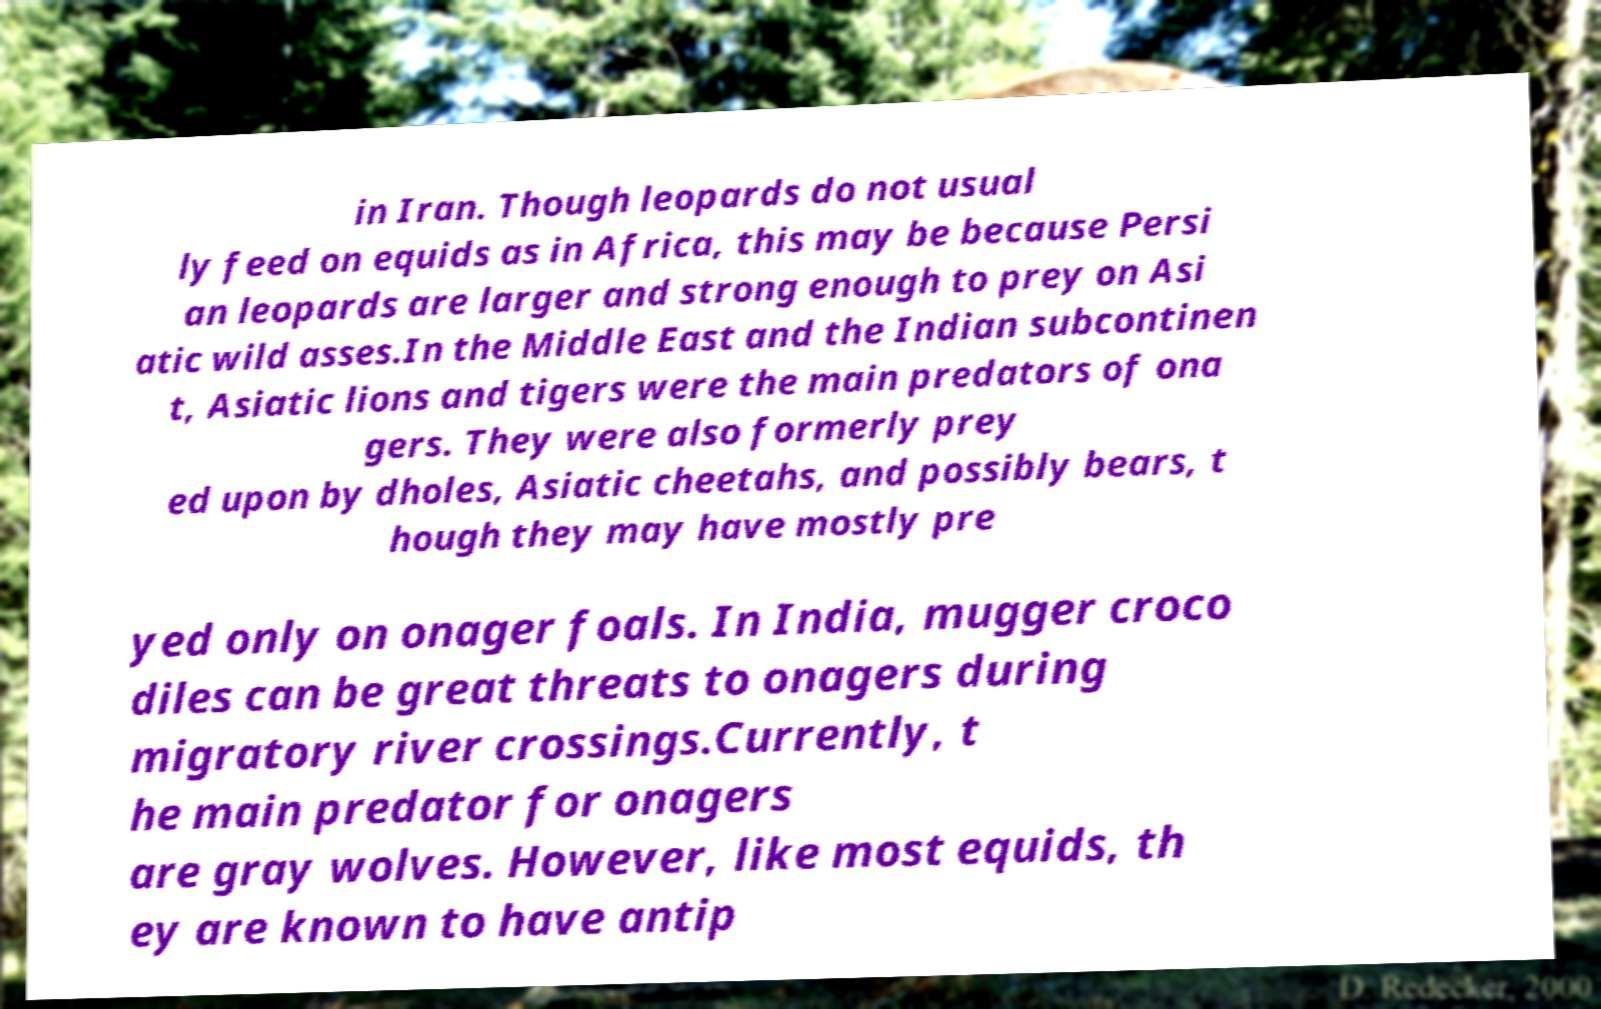Could you extract and type out the text from this image? in Iran. Though leopards do not usual ly feed on equids as in Africa, this may be because Persi an leopards are larger and strong enough to prey on Asi atic wild asses.In the Middle East and the Indian subcontinen t, Asiatic lions and tigers were the main predators of ona gers. They were also formerly prey ed upon by dholes, Asiatic cheetahs, and possibly bears, t hough they may have mostly pre yed only on onager foals. In India, mugger croco diles can be great threats to onagers during migratory river crossings.Currently, t he main predator for onagers are gray wolves. However, like most equids, th ey are known to have antip 